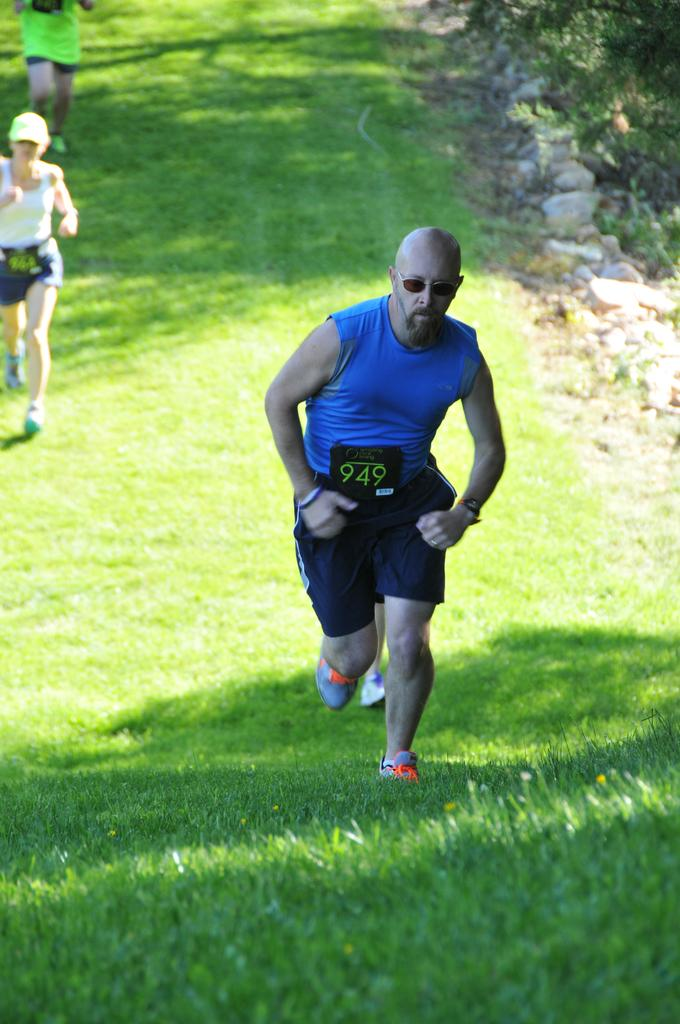What are the people in the image doing? The people in the image are running. On what surface are the people running? The people are running on the grass. What other elements can be seen in the image? Rocks and stones are visible in the image. What type of cave can be seen in the image? There is no cave present in the image; it features people running on the grass with rocks and stones visible. 